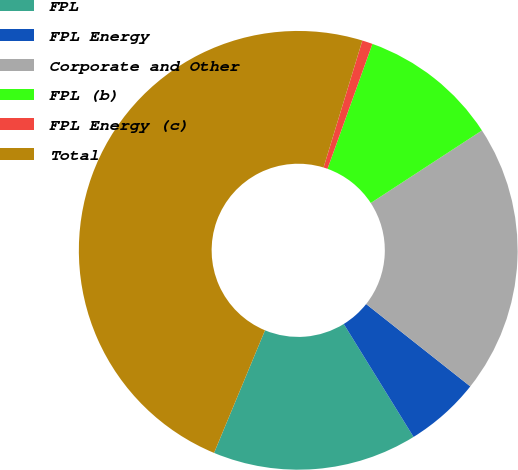Convert chart. <chart><loc_0><loc_0><loc_500><loc_500><pie_chart><fcel>FPL<fcel>FPL Energy<fcel>Corporate and Other<fcel>FPL (b)<fcel>FPL Energy (c)<fcel>Total<nl><fcel>15.08%<fcel>5.54%<fcel>19.85%<fcel>10.31%<fcel>0.77%<fcel>48.46%<nl></chart> 